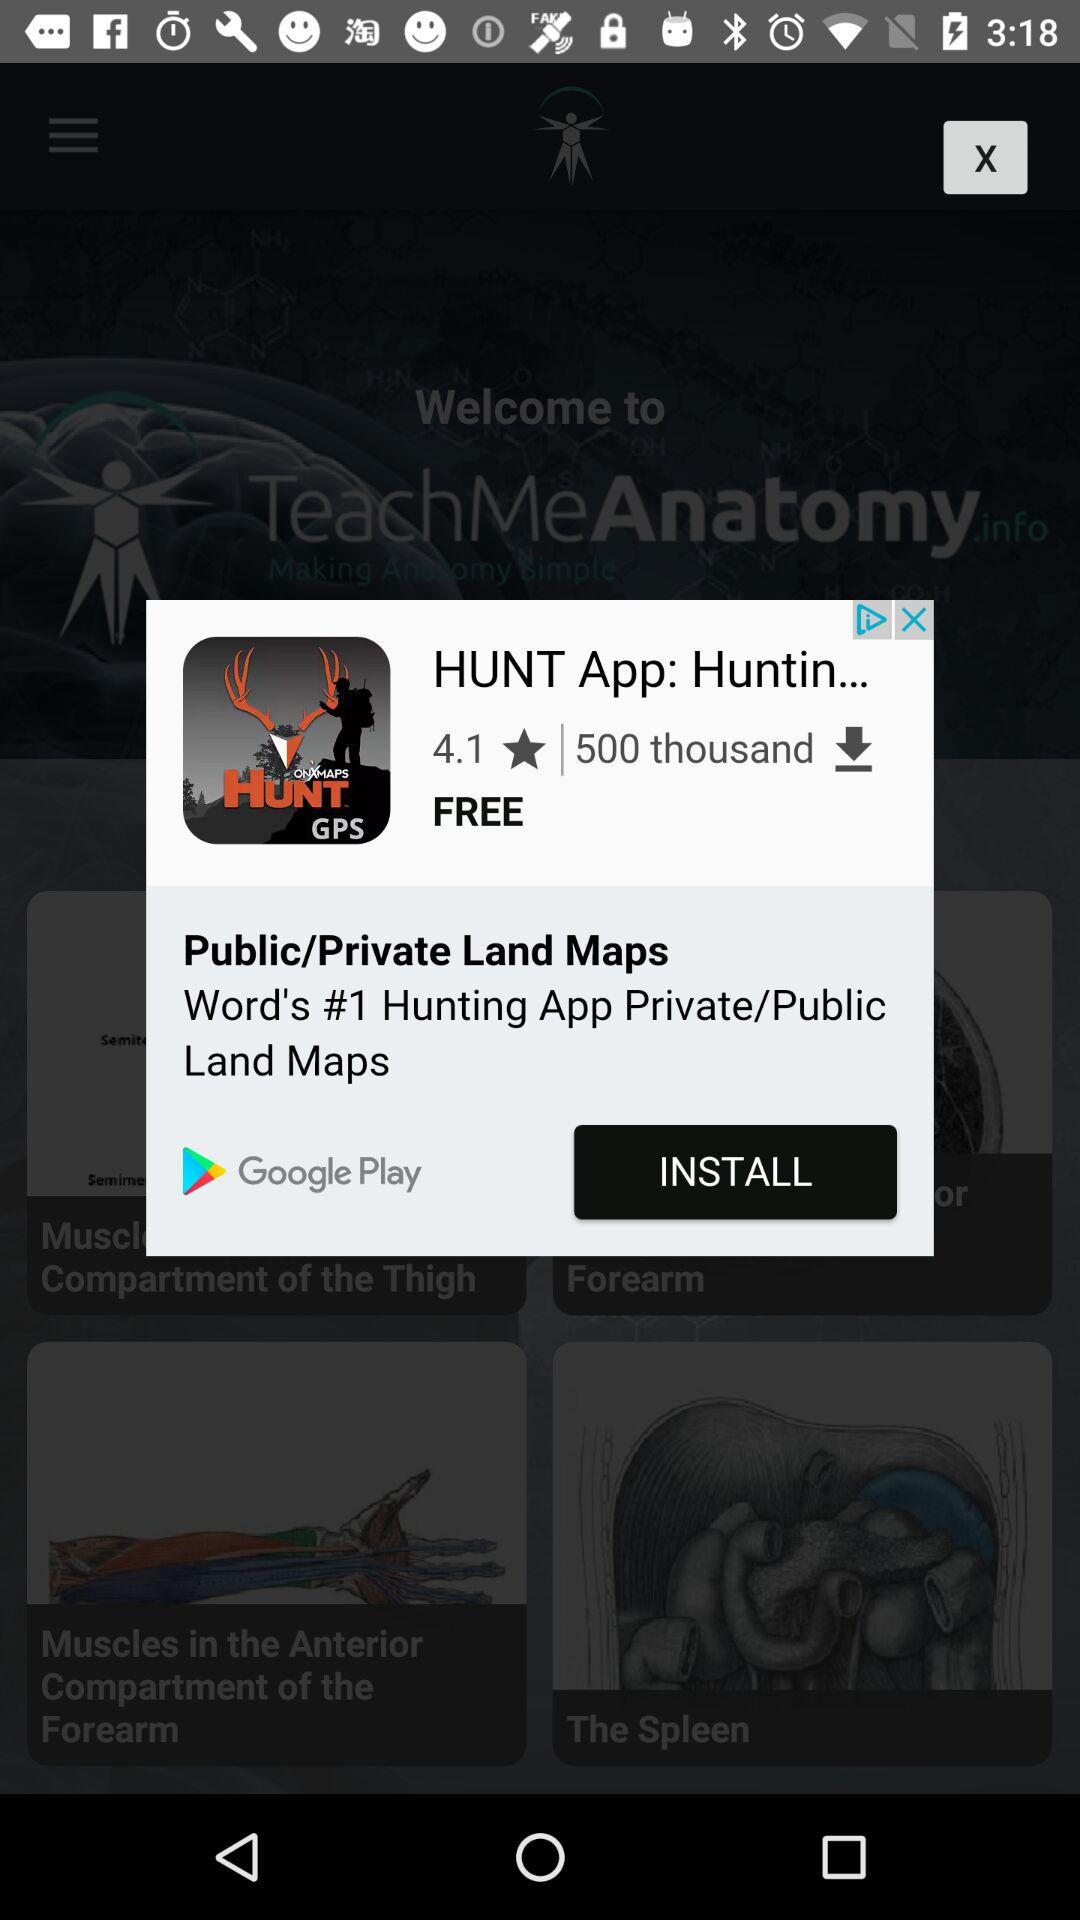Is the "HUNT" application free? The "HUNT" application is free. 